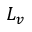Convert formula to latex. <formula><loc_0><loc_0><loc_500><loc_500>L _ { v }</formula> 